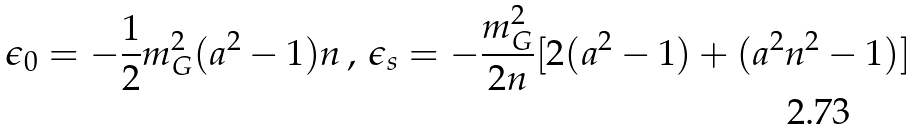<formula> <loc_0><loc_0><loc_500><loc_500>\epsilon _ { 0 } = - \frac { 1 } { 2 } m _ { G } ^ { 2 } ( a ^ { 2 } - 1 ) n \, , \, \epsilon _ { s } = - \frac { m _ { G } ^ { 2 } } { 2 n } [ 2 ( a ^ { 2 } - 1 ) + ( a ^ { 2 } n ^ { 2 } - 1 ) ]</formula> 